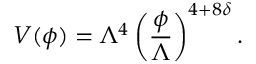<formula> <loc_0><loc_0><loc_500><loc_500>V ( \phi ) = \Lambda ^ { 4 } \left ( \frac { \phi } { \Lambda } \right ) ^ { 4 + 8 \delta } .</formula> 